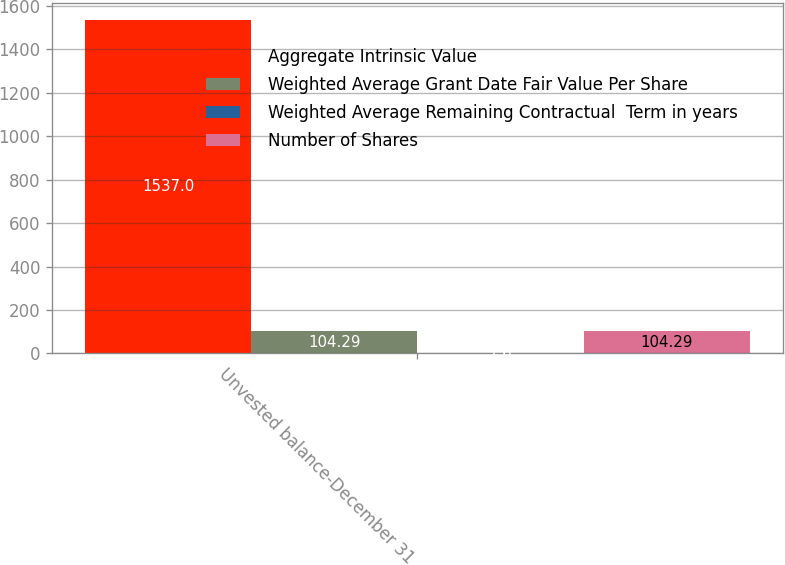Convert chart. <chart><loc_0><loc_0><loc_500><loc_500><stacked_bar_chart><ecel><fcel>Unvested balance-December 31<nl><fcel>Aggregate Intrinsic Value<fcel>1537<nl><fcel>Weighted Average Grant Date Fair Value Per Share<fcel>104.29<nl><fcel>Weighted Average Remaining Contractual  Term in years<fcel>1.6<nl><fcel>Number of Shares<fcel>104.29<nl></chart> 